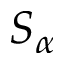Convert formula to latex. <formula><loc_0><loc_0><loc_500><loc_500>S _ { \alpha }</formula> 